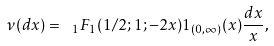<formula> <loc_0><loc_0><loc_500><loc_500>\nu ( d x ) = \ _ { 1 } F _ { 1 } ( 1 / 2 ; 1 ; - 2 x ) 1 _ { ( 0 , \infty ) } ( x ) \frac { d x } { x } ,</formula> 